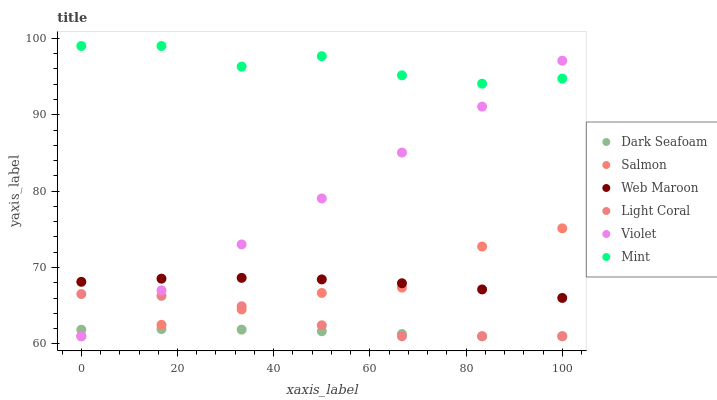Does Dark Seafoam have the minimum area under the curve?
Answer yes or no. Yes. Does Mint have the maximum area under the curve?
Answer yes or no. Yes. Does Web Maroon have the minimum area under the curve?
Answer yes or no. No. Does Web Maroon have the maximum area under the curve?
Answer yes or no. No. Is Violet the smoothest?
Answer yes or no. Yes. Is Mint the roughest?
Answer yes or no. Yes. Is Web Maroon the smoothest?
Answer yes or no. No. Is Web Maroon the roughest?
Answer yes or no. No. Does Salmon have the lowest value?
Answer yes or no. Yes. Does Web Maroon have the lowest value?
Answer yes or no. No. Does Mint have the highest value?
Answer yes or no. Yes. Does Web Maroon have the highest value?
Answer yes or no. No. Is Light Coral less than Mint?
Answer yes or no. Yes. Is Mint greater than Light Coral?
Answer yes or no. Yes. Does Salmon intersect Light Coral?
Answer yes or no. Yes. Is Salmon less than Light Coral?
Answer yes or no. No. Is Salmon greater than Light Coral?
Answer yes or no. No. Does Light Coral intersect Mint?
Answer yes or no. No. 